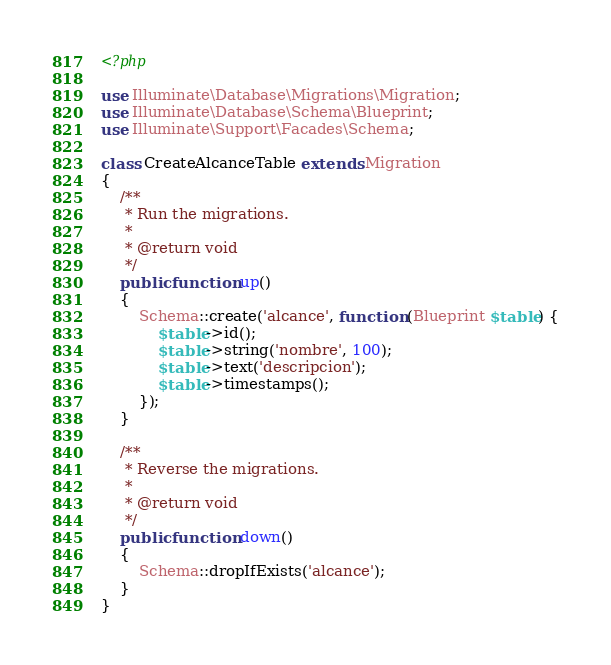Convert code to text. <code><loc_0><loc_0><loc_500><loc_500><_PHP_><?php

use Illuminate\Database\Migrations\Migration;
use Illuminate\Database\Schema\Blueprint;
use Illuminate\Support\Facades\Schema;

class CreateAlcanceTable extends Migration
{
    /**
     * Run the migrations.
     *
     * @return void
     */
    public function up()
    {
        Schema::create('alcance', function (Blueprint $table) {
            $table->id();
            $table->string('nombre', 100);
            $table->text('descripcion');
            $table->timestamps();
        });
    }

    /**
     * Reverse the migrations.
     *
     * @return void
     */
    public function down()
    {
        Schema::dropIfExists('alcance');
    }
}
</code> 